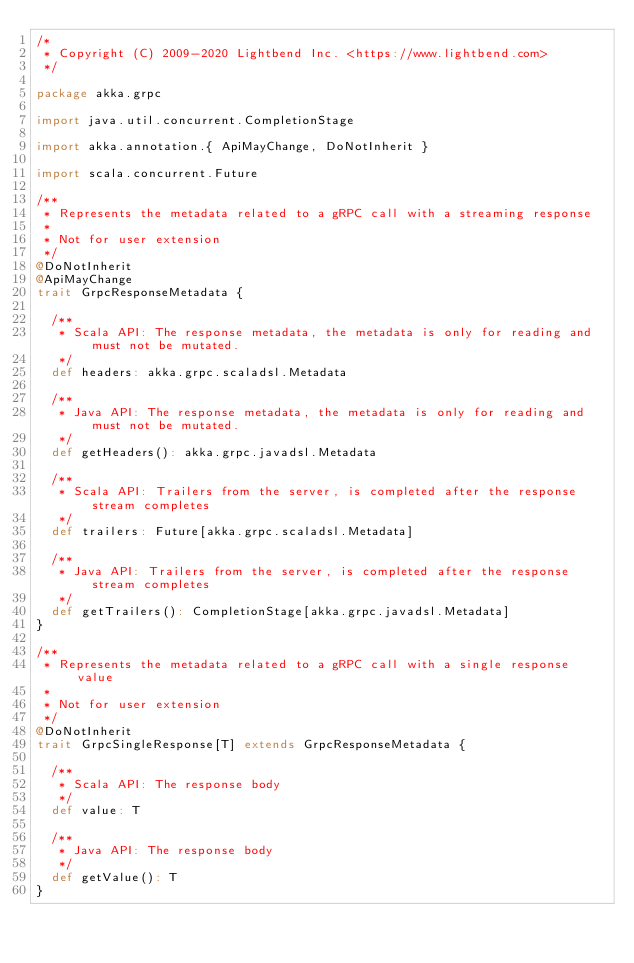<code> <loc_0><loc_0><loc_500><loc_500><_Scala_>/*
 * Copyright (C) 2009-2020 Lightbend Inc. <https://www.lightbend.com>
 */

package akka.grpc

import java.util.concurrent.CompletionStage

import akka.annotation.{ ApiMayChange, DoNotInherit }

import scala.concurrent.Future

/**
 * Represents the metadata related to a gRPC call with a streaming response
 *
 * Not for user extension
 */
@DoNotInherit
@ApiMayChange
trait GrpcResponseMetadata {

  /**
   * Scala API: The response metadata, the metadata is only for reading and must not be mutated.
   */
  def headers: akka.grpc.scaladsl.Metadata

  /**
   * Java API: The response metadata, the metadata is only for reading and must not be mutated.
   */
  def getHeaders(): akka.grpc.javadsl.Metadata

  /**
   * Scala API: Trailers from the server, is completed after the response stream completes
   */
  def trailers: Future[akka.grpc.scaladsl.Metadata]

  /**
   * Java API: Trailers from the server, is completed after the response stream completes
   */
  def getTrailers(): CompletionStage[akka.grpc.javadsl.Metadata]
}

/**
 * Represents the metadata related to a gRPC call with a single response value
 *
 * Not for user extension
 */
@DoNotInherit
trait GrpcSingleResponse[T] extends GrpcResponseMetadata {

  /**
   * Scala API: The response body
   */
  def value: T

  /**
   * Java API: The response body
   */
  def getValue(): T
}
</code> 